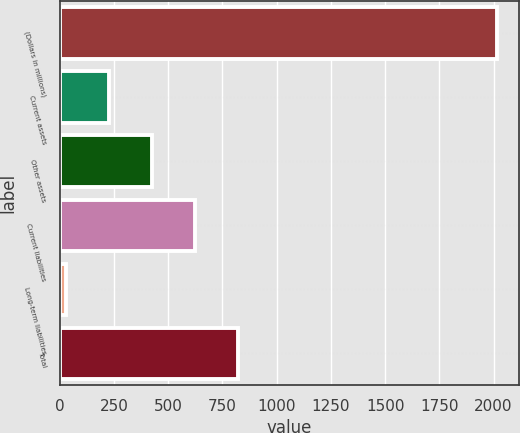<chart> <loc_0><loc_0><loc_500><loc_500><bar_chart><fcel>(Dollars in millions)<fcel>Current assets<fcel>Other assets<fcel>Current liabilities<fcel>Long-term liabilities<fcel>Total<nl><fcel>2016<fcel>227.7<fcel>426.4<fcel>625.1<fcel>29<fcel>823.8<nl></chart> 